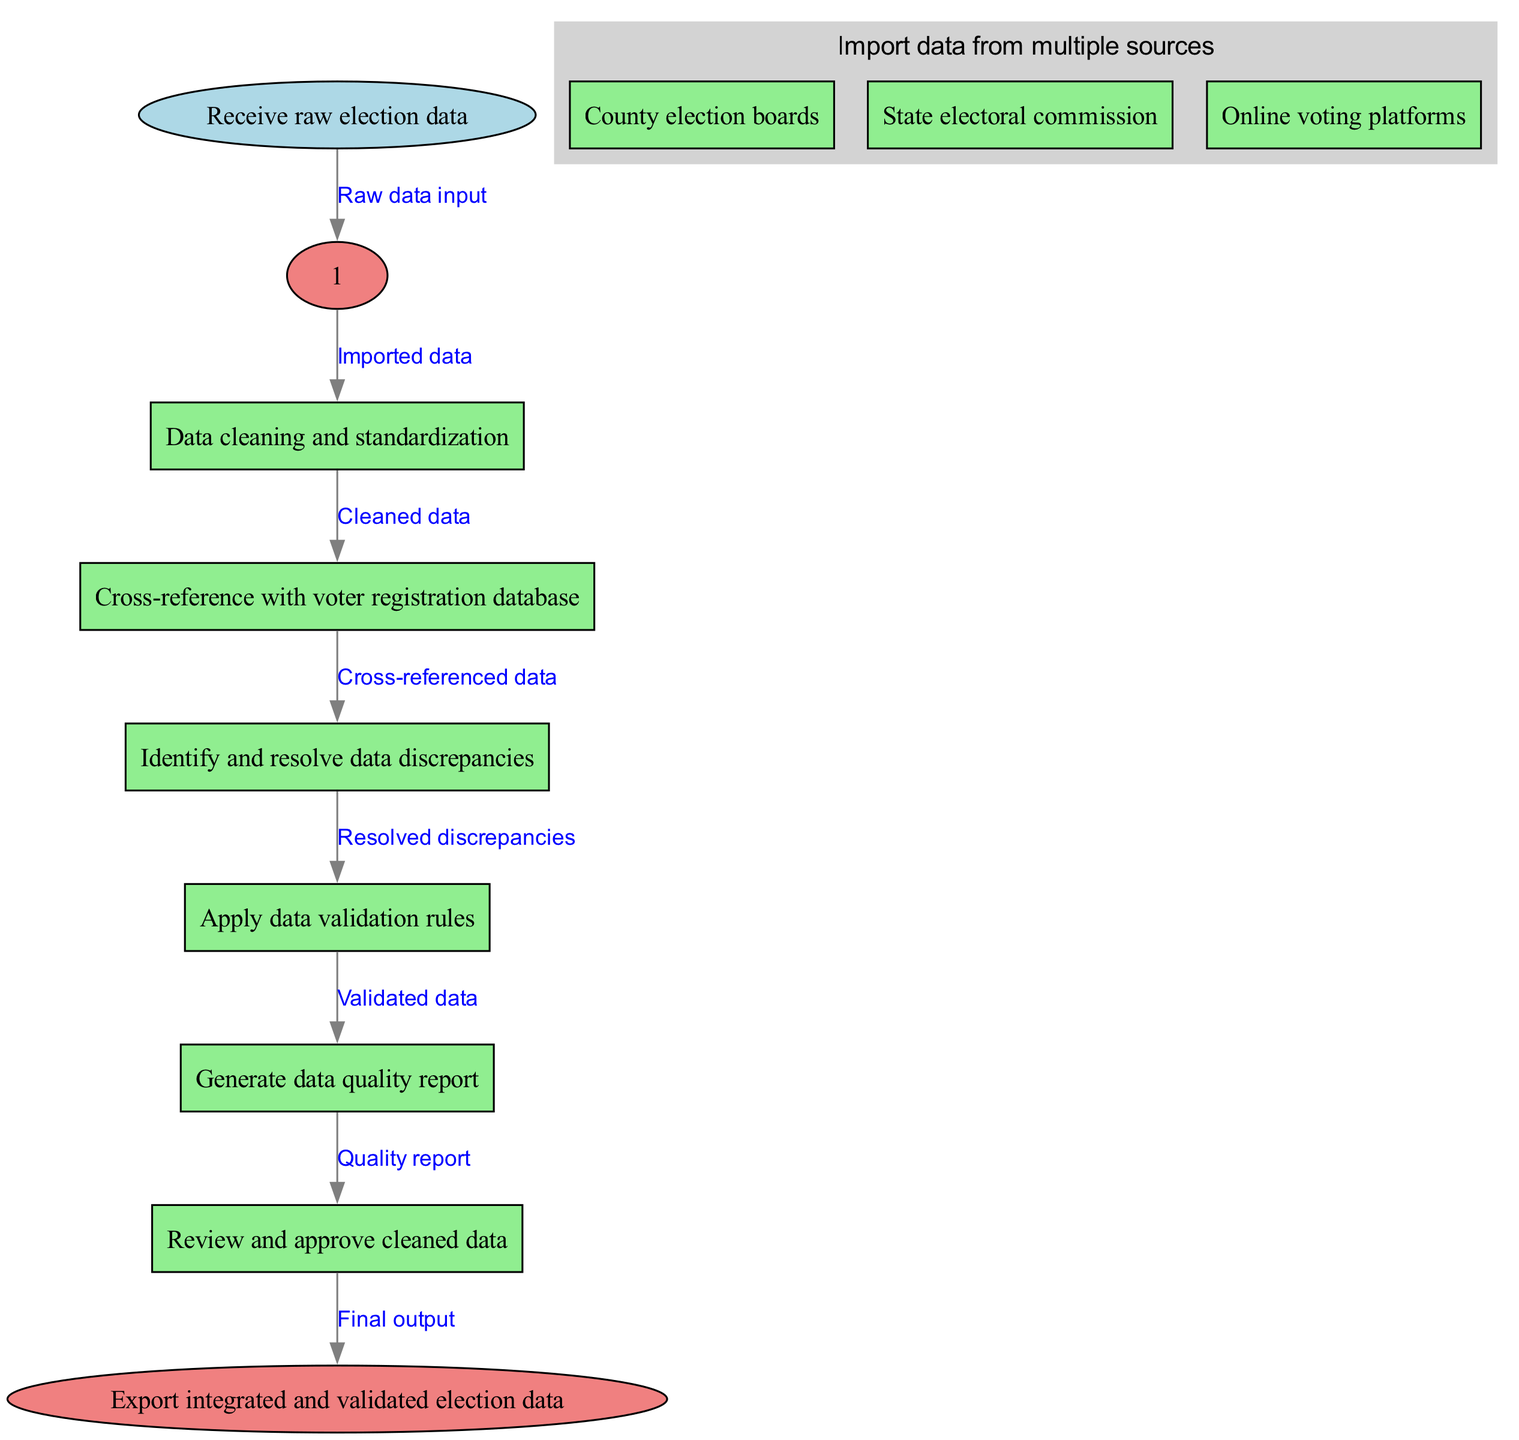What is the first step in the clinical pathway? The diagram starts with the node labeled "Receive raw election data," indicating it is the first action to be taken.
Answer: Receive raw election data How many main nodes are there in the pathway? By counting the numbered main nodes listed, we see there are a total of six nodes (excluding start and end).
Answer: Six What are the sub-sources of data in the first step? The first node lists "County election boards," "State electoral commission," and "Online voting platforms" as sub-sources, indicating these are the sources from which data is imported.
Answer: County election boards, State electoral commission, Online voting platforms What is the output of the pathway? The diagram terminates at the end node labeled "Export integrated and validated election data," which indicates the final product of the entire clinical pathway.
Answer: Export integrated and validated election data Which node follows the data cleaning and standardization step? The flow from the data cleaning and standardization step, labeled as node two, leads directly to node three, which is "Cross-reference with voter registration database."
Answer: Cross-reference with voter registration database What action occurs after identifying and resolving data discrepancies? The next action, as indicated by the nodes' flow, is applying data validation rules, which follows that node in the pathway.
Answer: Apply data validation rules What does the data quality report assess? The data quality report, produced after applying data validation rules, assesses the quality of the validated data before it is reviewed and approved.
Answer: Quality of validated data How is the data approved in the pathway? The flow indicates that after generating the data quality report, the next step is to review and approve the cleaned data, suggesting that this is the approval process.
Answer: Review and approve cleaned data 